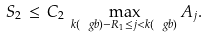<formula> <loc_0><loc_0><loc_500><loc_500>S _ { 2 } \, \leq \, C _ { 2 } \, \max _ { k ( \ g b ) - R _ { 1 } \leq j < k ( \ g b ) } A _ { j } .</formula> 